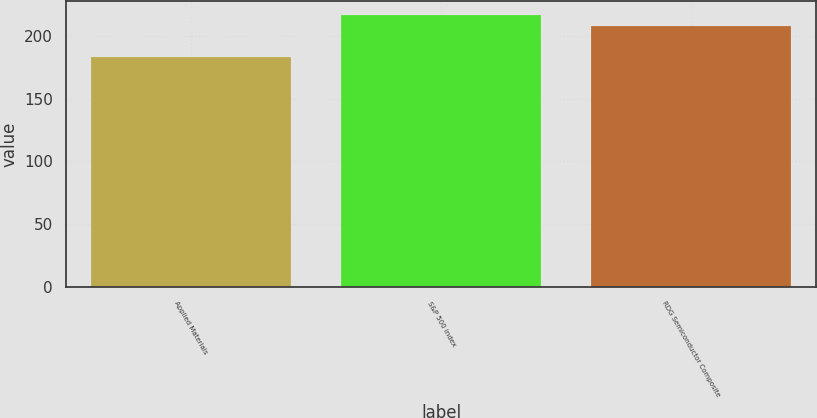Convert chart. <chart><loc_0><loc_0><loc_500><loc_500><bar_chart><fcel>Applied Materials<fcel>S&P 500 Index<fcel>RDG Semiconductor Composite<nl><fcel>183.29<fcel>216.39<fcel>207.93<nl></chart> 